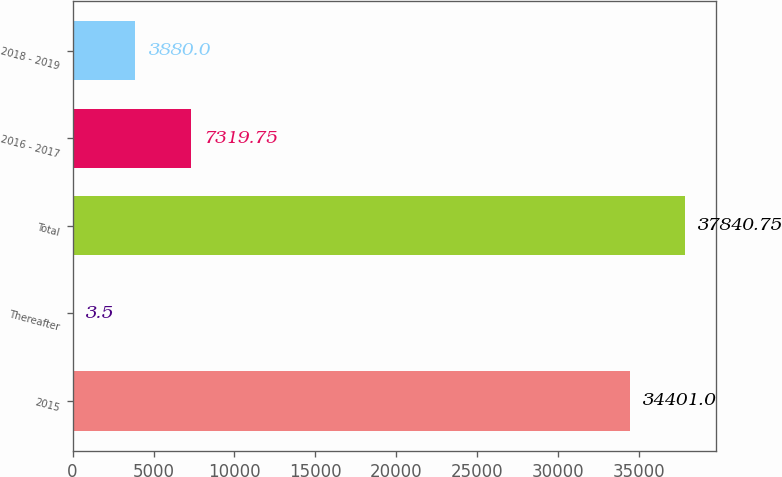<chart> <loc_0><loc_0><loc_500><loc_500><bar_chart><fcel>2015<fcel>Thereafter<fcel>Total<fcel>2016 - 2017<fcel>2018 - 2019<nl><fcel>34401<fcel>3.5<fcel>37840.8<fcel>7319.75<fcel>3880<nl></chart> 